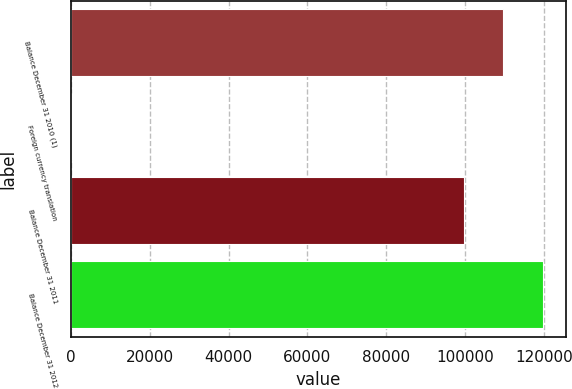Convert chart. <chart><loc_0><loc_0><loc_500><loc_500><bar_chart><fcel>Balance December 31 2010 (1)<fcel>Foreign currency translation<fcel>Balance December 31 2011<fcel>Balance December 31 2012<nl><fcel>109698<fcel>140<fcel>99677<fcel>119719<nl></chart> 